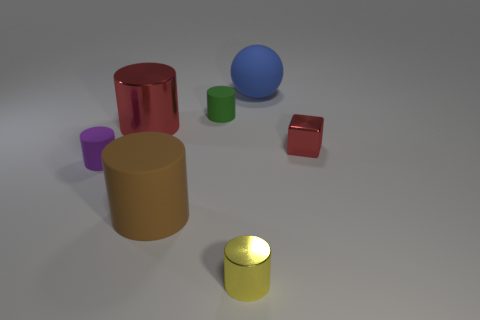There is a metallic object that is the same color as the metal cube; what shape is it?
Your response must be concise. Cylinder. Does the object on the right side of the big matte sphere have the same color as the metal cylinder that is behind the purple rubber cylinder?
Offer a terse response. Yes. The thing that is the same color as the tiny metal cube is what size?
Give a very brief answer. Large. Is the number of large things greater than the number of tiny yellow metallic things?
Provide a succinct answer. Yes. Is the color of the metallic object in front of the small block the same as the metallic cube?
Provide a short and direct response. No. What number of things are either tiny things that are behind the small purple matte cylinder or tiny matte cylinders that are behind the red block?
Make the answer very short. 2. What number of large things are behind the metal cube and to the left of the small metallic cylinder?
Make the answer very short. 1. Is the large ball made of the same material as the purple object?
Your answer should be very brief. Yes. There is a big rubber thing in front of the small matte thing that is behind the red metal thing that is on the right side of the yellow shiny object; what shape is it?
Offer a very short reply. Cylinder. The cylinder that is in front of the small purple cylinder and to the right of the large brown object is made of what material?
Offer a terse response. Metal. 